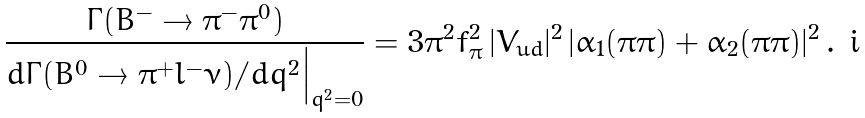<formula> <loc_0><loc_0><loc_500><loc_500>\frac { \Gamma ( B ^ { - } \to \pi ^ { - } \pi ^ { 0 } ) } { d \Gamma ( \bar { B } ^ { 0 } \to \pi ^ { + } l ^ { - } \bar { \nu } ) / d q ^ { 2 } \Big | _ { q ^ { 2 } = 0 } } = 3 \pi ^ { 2 } f _ { \pi } ^ { 2 } \, | V _ { u d } | ^ { 2 } \, | \alpha _ { 1 } ( \pi \pi ) + \alpha _ { 2 } ( \pi \pi ) | ^ { 2 } \, .</formula> 